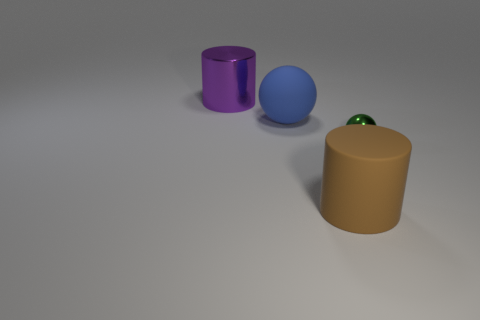Are there any other things that are the same size as the green shiny ball?
Make the answer very short. No. How many things are either objects behind the blue rubber object or big cylinders that are left of the large sphere?
Offer a terse response. 1. How many other objects are there of the same shape as the blue thing?
Give a very brief answer. 1. What number of other objects are the same size as the brown thing?
Ensure brevity in your answer.  2. Does the large sphere have the same material as the large brown cylinder?
Your answer should be compact. Yes. There is a cylinder that is behind the shiny thing that is in front of the big blue sphere; what is its color?
Keep it short and to the point. Purple. There is another object that is the same shape as the green metallic thing; what size is it?
Ensure brevity in your answer.  Large. There is a large cylinder behind the cylinder that is to the right of the big blue matte ball; what number of purple cylinders are behind it?
Provide a short and direct response. 0. Is the number of large blue spheres greater than the number of large gray metallic spheres?
Offer a terse response. Yes. What number of brown things are there?
Your answer should be compact. 1. 